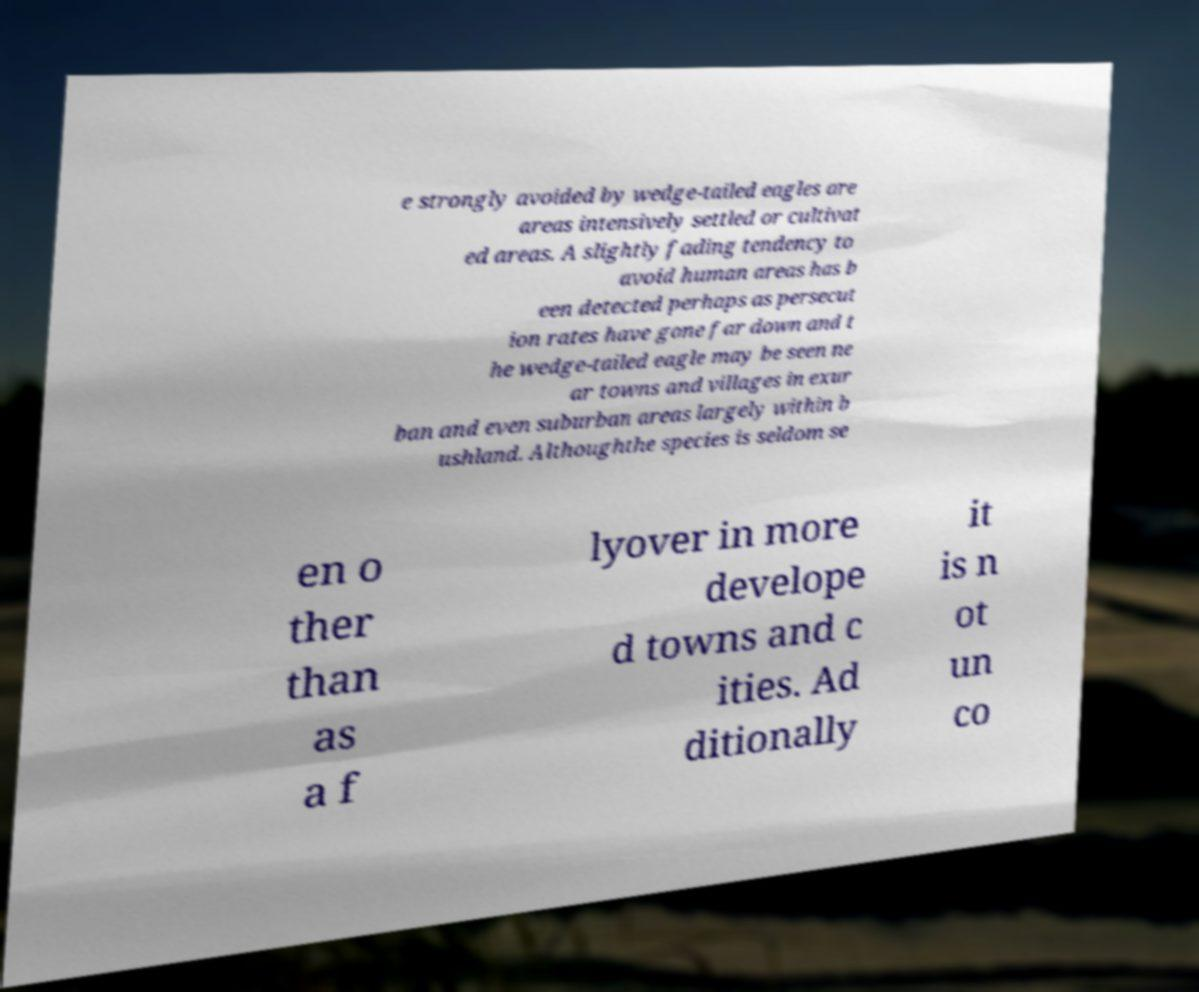Could you extract and type out the text from this image? e strongly avoided by wedge-tailed eagles are areas intensively settled or cultivat ed areas. A slightly fading tendency to avoid human areas has b een detected perhaps as persecut ion rates have gone far down and t he wedge-tailed eagle may be seen ne ar towns and villages in exur ban and even suburban areas largely within b ushland. Althoughthe species is seldom se en o ther than as a f lyover in more develope d towns and c ities. Ad ditionally it is n ot un co 